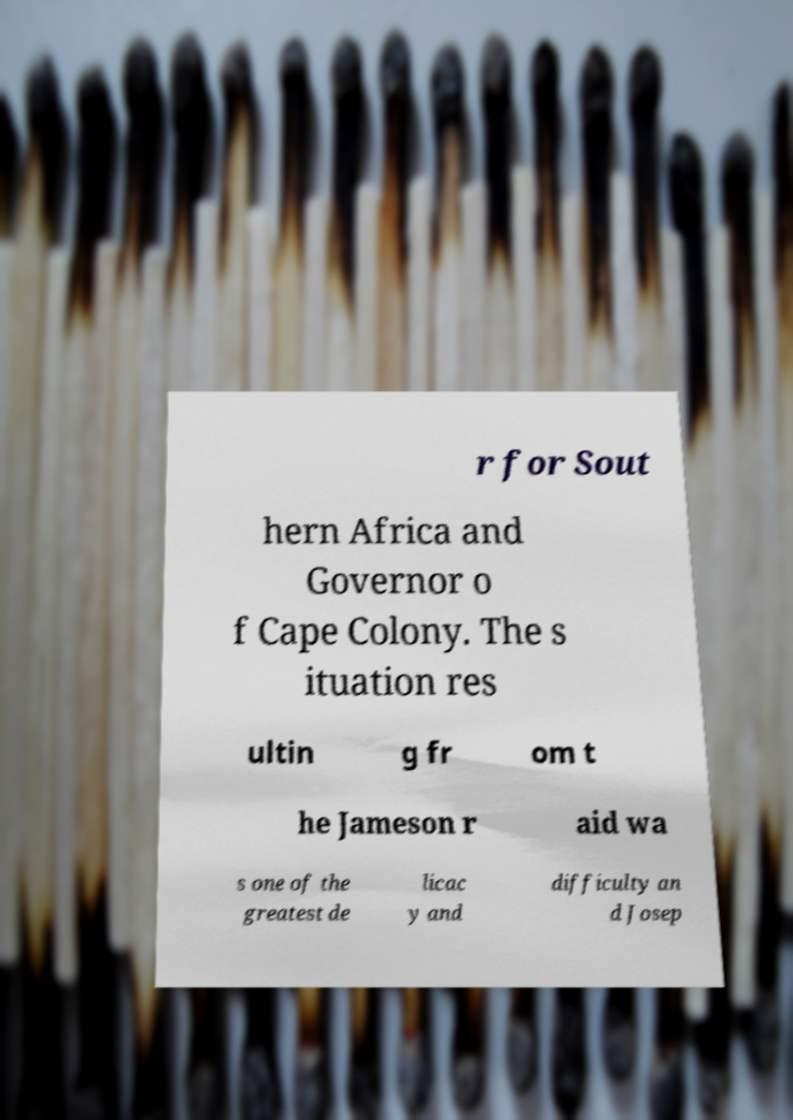What messages or text are displayed in this image? I need them in a readable, typed format. r for Sout hern Africa and Governor o f Cape Colony. The s ituation res ultin g fr om t he Jameson r aid wa s one of the greatest de licac y and difficulty an d Josep 